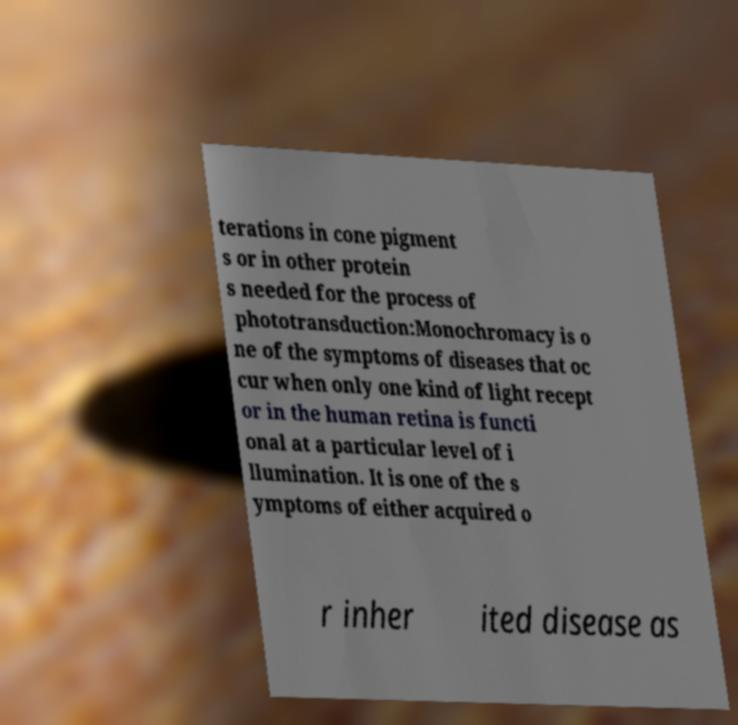What messages or text are displayed in this image? I need them in a readable, typed format. terations in cone pigment s or in other protein s needed for the process of phototransduction:Monochromacy is o ne of the symptoms of diseases that oc cur when only one kind of light recept or in the human retina is functi onal at a particular level of i llumination. It is one of the s ymptoms of either acquired o r inher ited disease as 